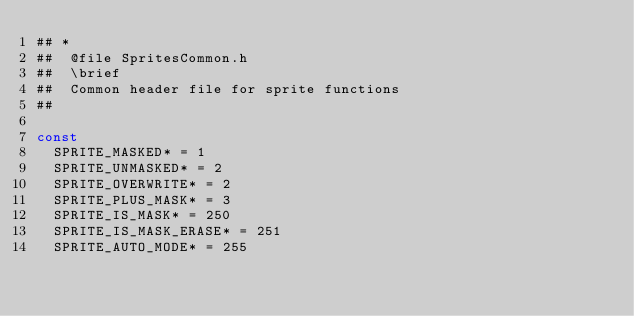Convert code to text. <code><loc_0><loc_0><loc_500><loc_500><_Nim_>## *
##  @file SpritesCommon.h
##  \brief
##  Common header file for sprite functions
##

const
  SPRITE_MASKED* = 1
  SPRITE_UNMASKED* = 2
  SPRITE_OVERWRITE* = 2
  SPRITE_PLUS_MASK* = 3
  SPRITE_IS_MASK* = 250
  SPRITE_IS_MASK_ERASE* = 251
  SPRITE_AUTO_MODE* = 255
</code> 